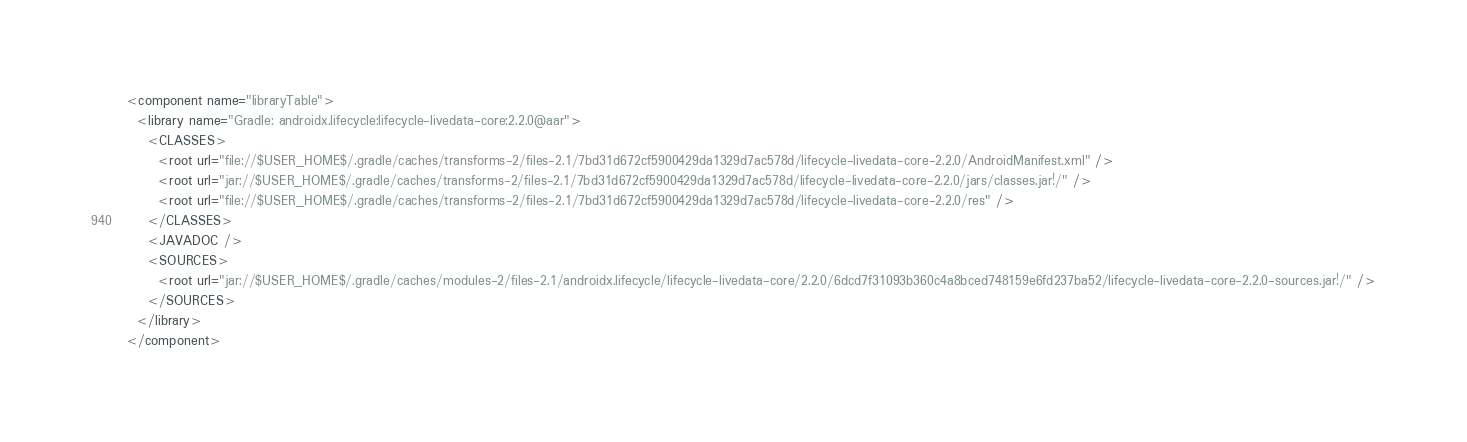Convert code to text. <code><loc_0><loc_0><loc_500><loc_500><_XML_><component name="libraryTable">
  <library name="Gradle: androidx.lifecycle:lifecycle-livedata-core:2.2.0@aar">
    <CLASSES>
      <root url="file://$USER_HOME$/.gradle/caches/transforms-2/files-2.1/7bd31d672cf5900429da1329d7ac578d/lifecycle-livedata-core-2.2.0/AndroidManifest.xml" />
      <root url="jar://$USER_HOME$/.gradle/caches/transforms-2/files-2.1/7bd31d672cf5900429da1329d7ac578d/lifecycle-livedata-core-2.2.0/jars/classes.jar!/" />
      <root url="file://$USER_HOME$/.gradle/caches/transforms-2/files-2.1/7bd31d672cf5900429da1329d7ac578d/lifecycle-livedata-core-2.2.0/res" />
    </CLASSES>
    <JAVADOC />
    <SOURCES>
      <root url="jar://$USER_HOME$/.gradle/caches/modules-2/files-2.1/androidx.lifecycle/lifecycle-livedata-core/2.2.0/6dcd7f31093b360c4a8bced748159e6fd237ba52/lifecycle-livedata-core-2.2.0-sources.jar!/" />
    </SOURCES>
  </library>
</component></code> 